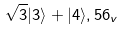Convert formula to latex. <formula><loc_0><loc_0><loc_500><loc_500>\sqrt { 3 } | 3 \rangle + | 4 \rangle , { 5 6 _ { v } }</formula> 